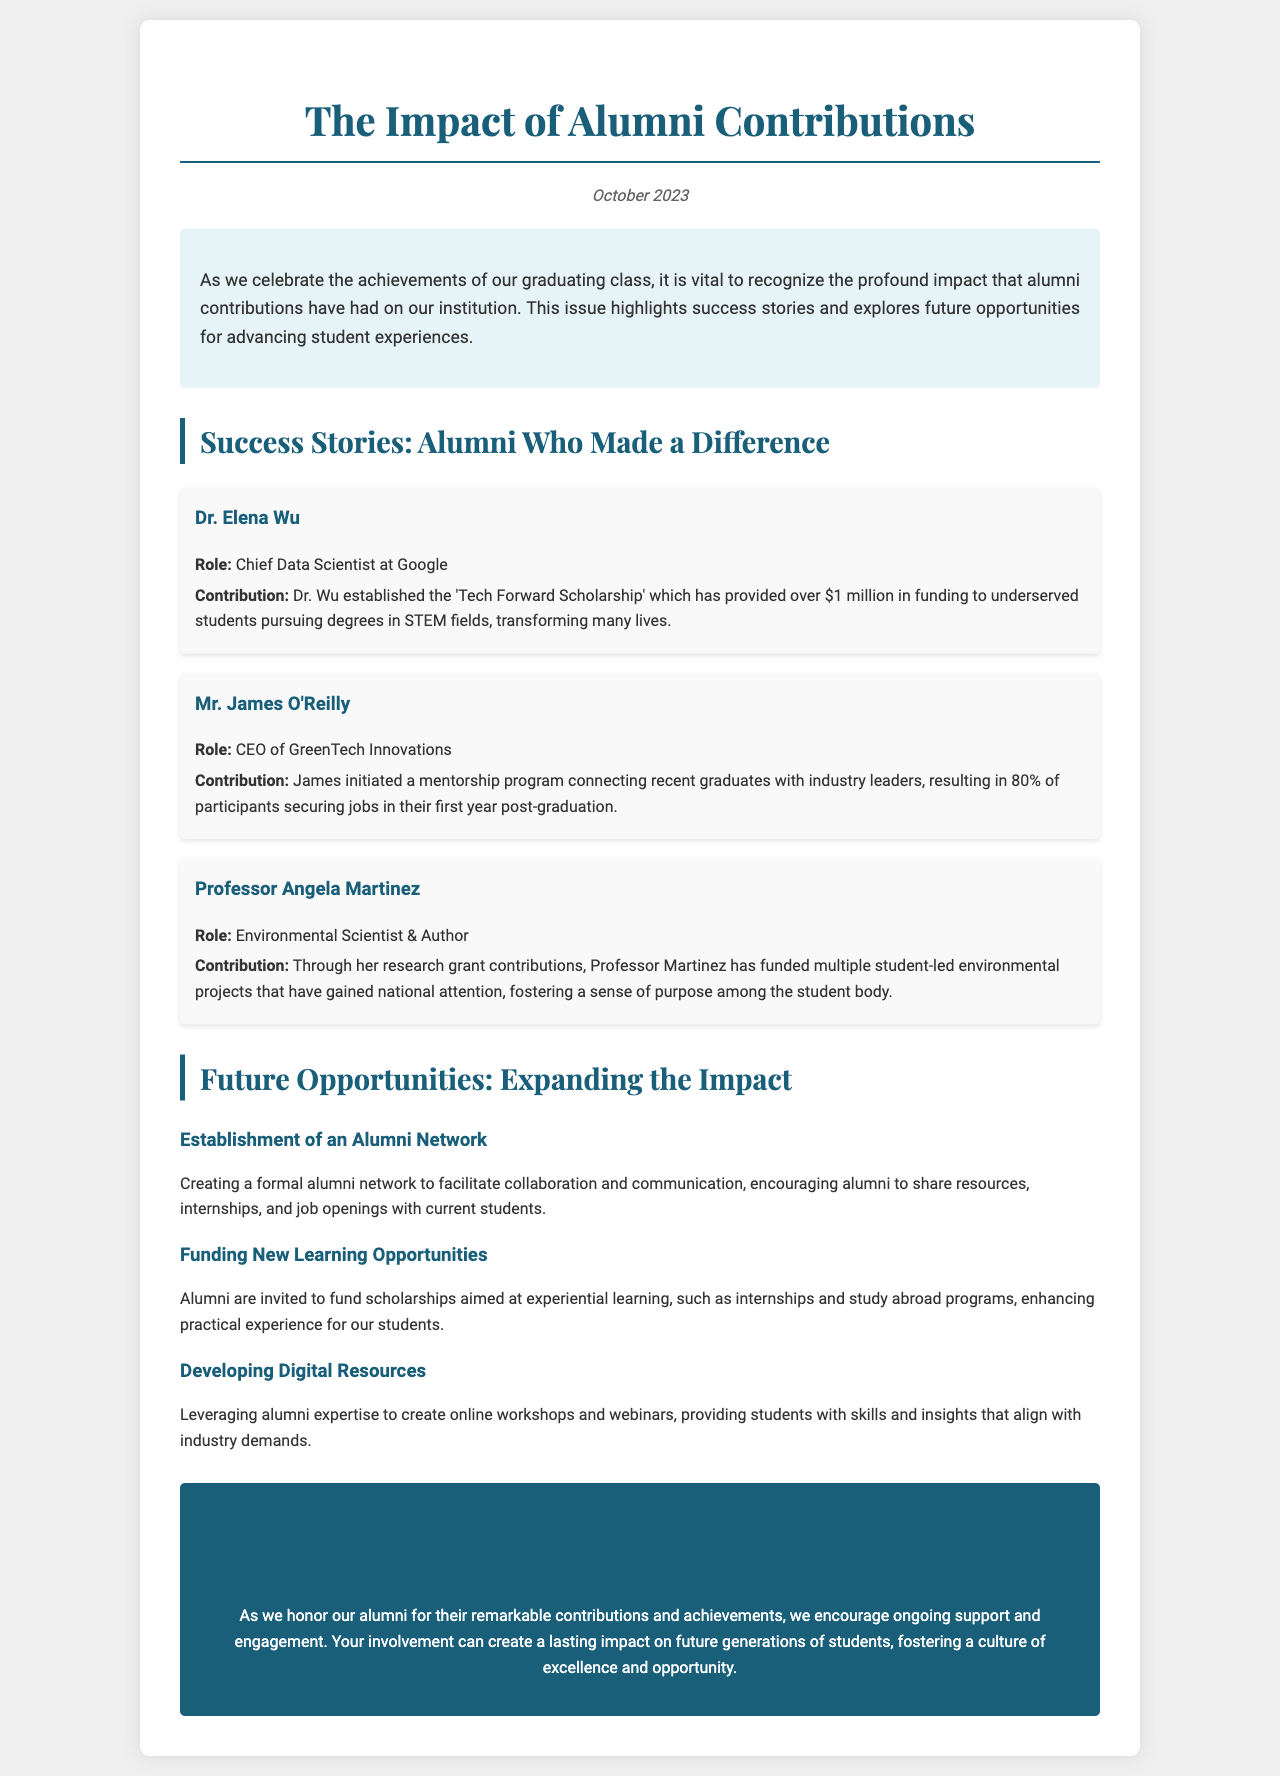What is the title of the newsletter? The title of the newsletter is presented at the top of the document and reads "The Impact of Alumni Contributions".
Answer: The Impact of Alumni Contributions Who is the Chief Data Scientist at Google mentioned in the newsletter? The newsletter identifies Dr. Elena Wu as the Chief Data Scientist at Google.
Answer: Dr. Elena Wu How much funding has the 'Tech Forward Scholarship' provided? The document states that the scholarship has provided over $1 million in funding.
Answer: over $1 million What percentage of participants secured jobs in their first year after joining the mentorship program? The newsletter notes that 80% of participants in the mentorship program secured jobs.
Answer: 80% What is one future opportunity suggested for alumni contributions? The document lists establishing an alumni network as one potential future opportunity.
Answer: Establishment of an Alumni Network Which alumni contribution gained national attention according to the document? The contribution by Professor Angela Martinez for funding student-led environmental projects gained national attention.
Answer: funding multiple student-led environmental projects What is the date of the newsletter? The newsletter prominently displays the date as October 2023.
Answer: October 2023 What type of resource development is suggested in the future opportunities section? The document suggests developing digital resources such as online workshops and webinars.
Answer: Developing Digital Resources What is the primary theme discussed in the introductory paragraph? The introduction discusses the profound impact of alumni contributions on the institution.
Answer: the impact of alumni contributions 